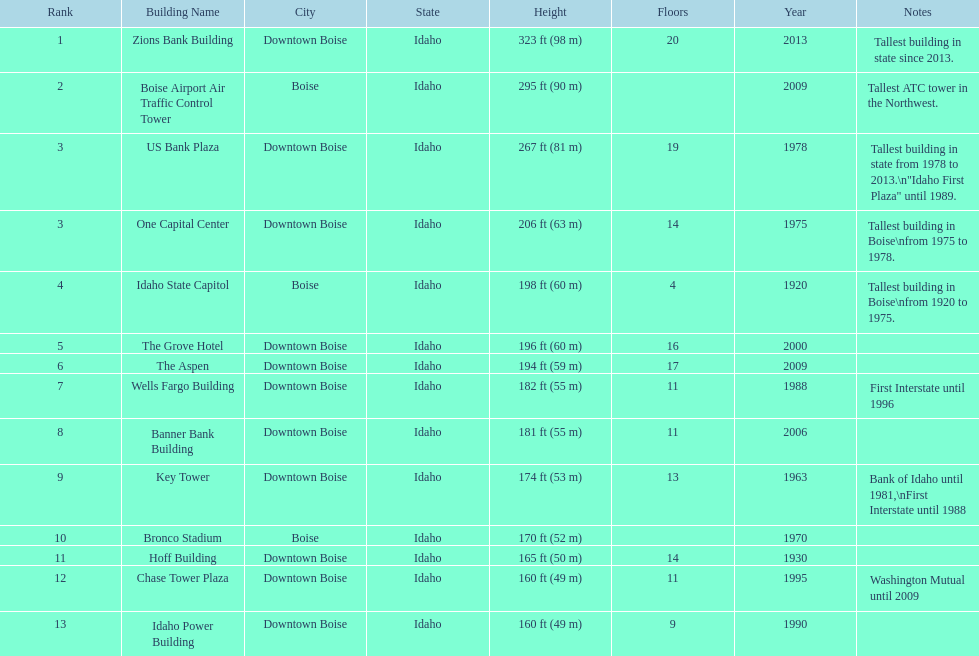What are the number of floors the us bank plaza has? 19. 